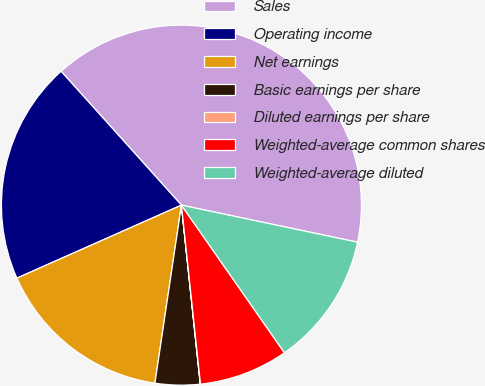<chart> <loc_0><loc_0><loc_500><loc_500><pie_chart><fcel>Sales<fcel>Operating income<fcel>Net earnings<fcel>Basic earnings per share<fcel>Diluted earnings per share<fcel>Weighted-average common shares<fcel>Weighted-average diluted<nl><fcel>39.96%<fcel>19.99%<fcel>16.0%<fcel>4.02%<fcel>0.02%<fcel>8.01%<fcel>12.0%<nl></chart> 